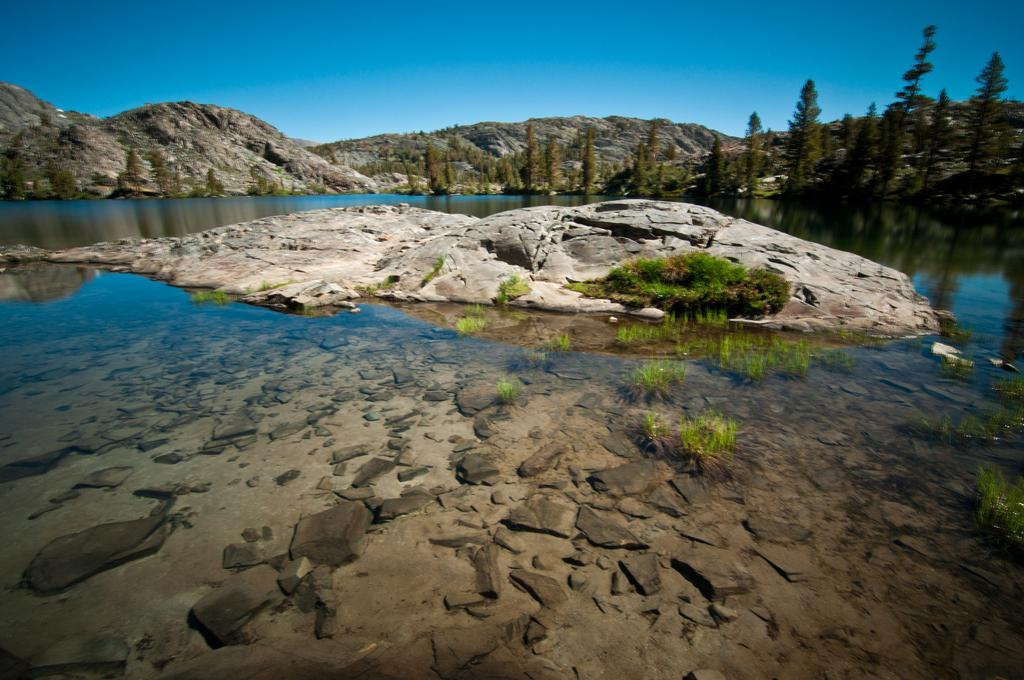What type of landform is present in the image? There is a hill in the image. What can be seen in front of the hill? Trees are visible in front of the hill. What body of water is present in the image? There is a lake in the image. What is visible at the top of the image? The sky is visible at the top of the image. What objects are floating on the lake? Some stones are visible on the lake. What type of vegetation is present on the lake? Grass is visible on the lake. What type of elbow can be seen supporting the horse in the image? There is no elbow or horse present in the image. 